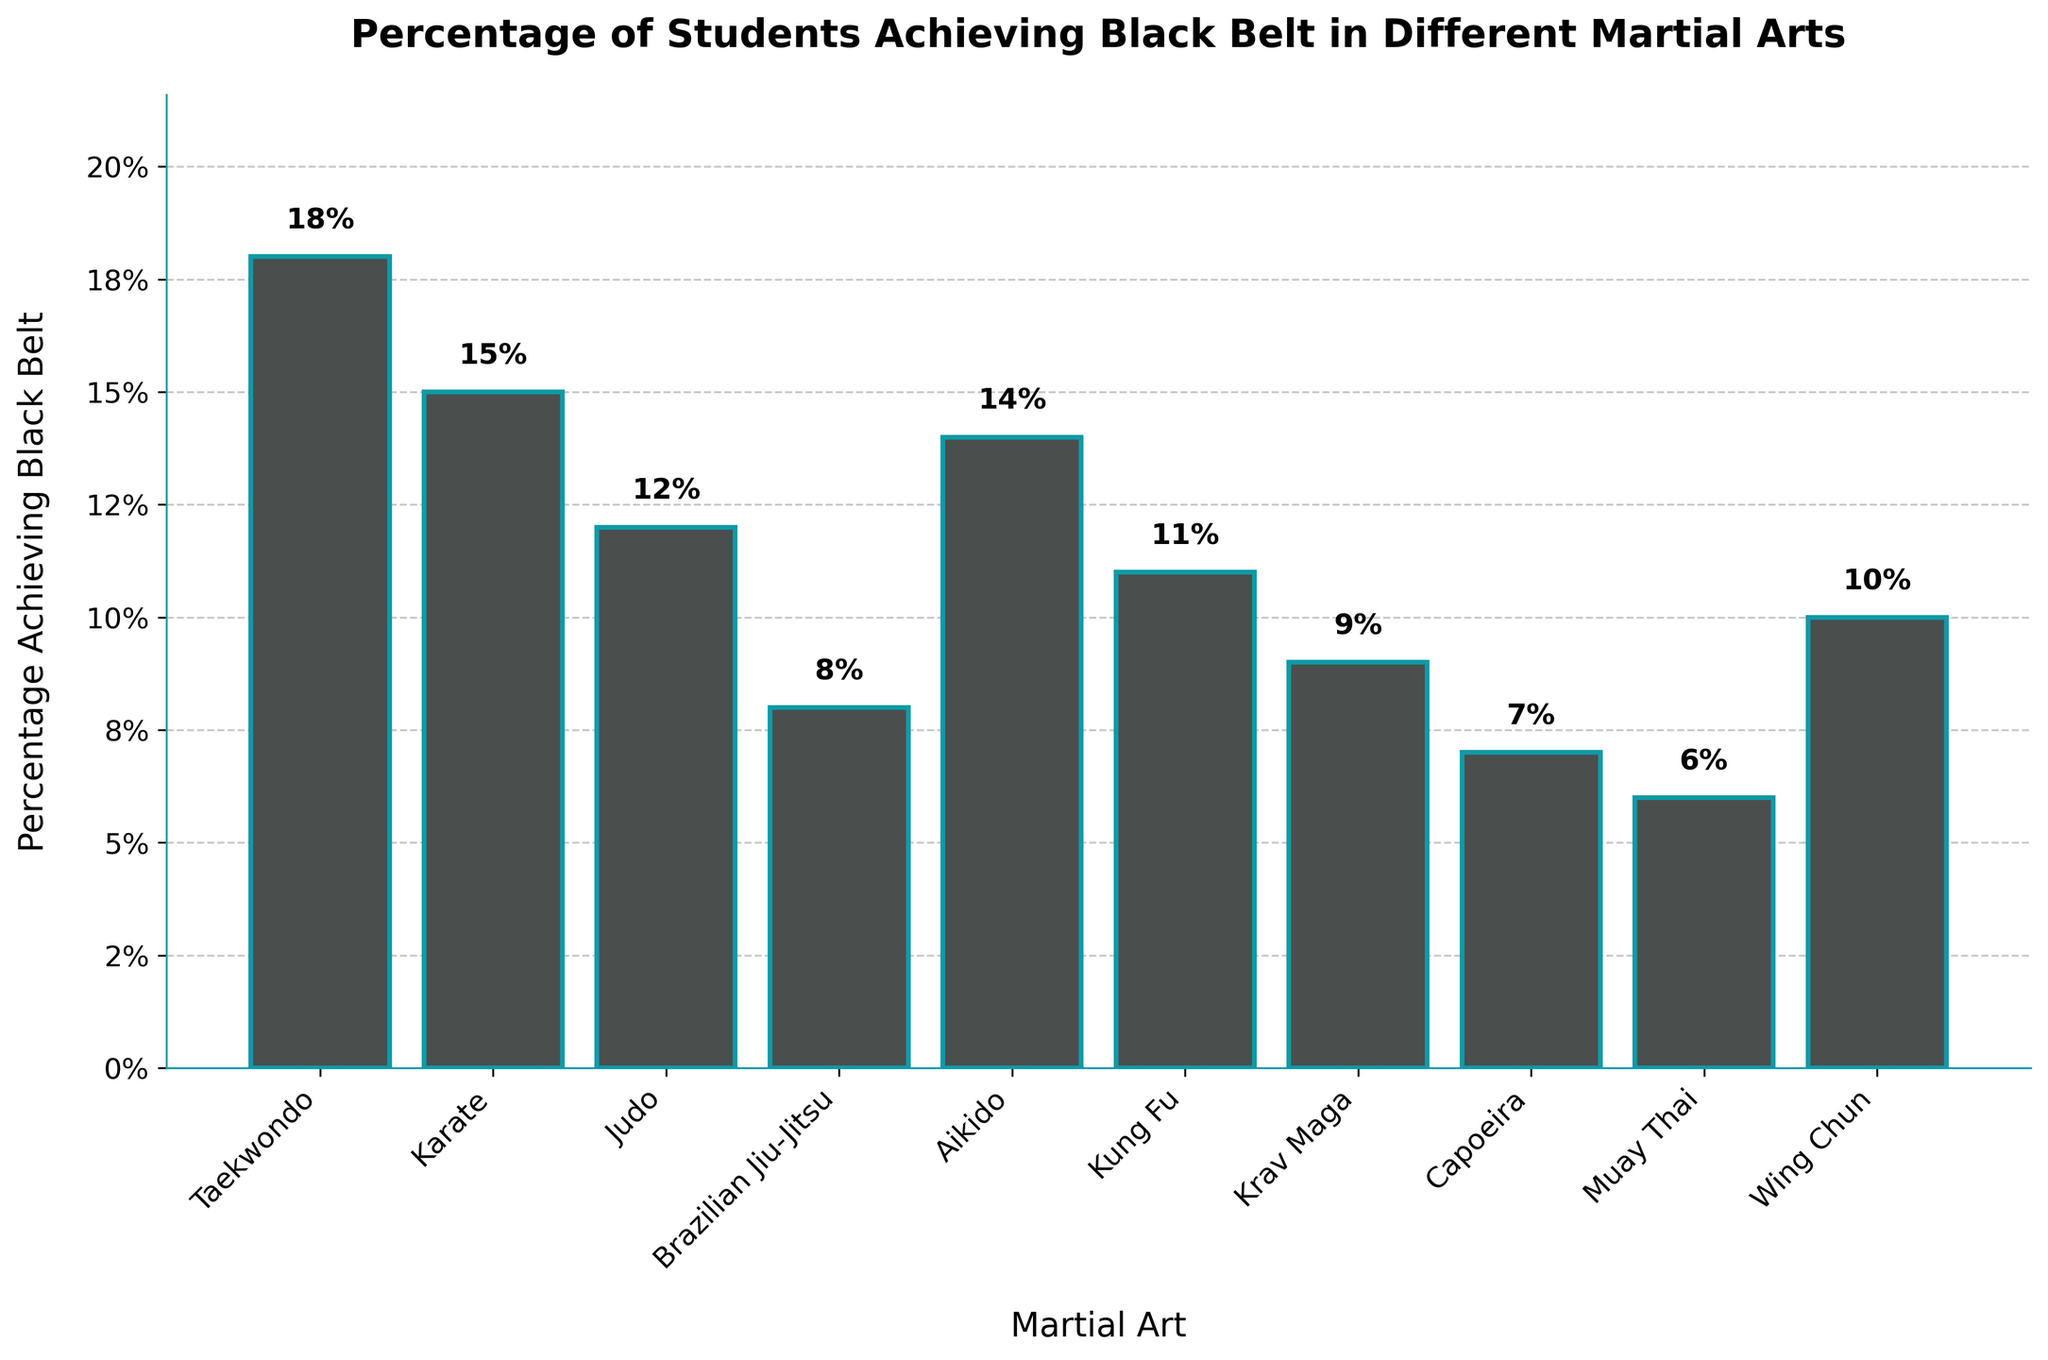What's the highest percentage of students achieving black belt among the martial arts listed? The figure shows a bar for each martial art with the percentage of students achieving black belt. The tallest bar represents the highest percentage. The Taekwondo bar is the tallest, indicating it has the highest percentage.
Answer: Taekwondo Which martial art has the lowest percentage of students achieving black belt? The figure shows a bar for each martial art. The shortest bar represents the lowest percentage of students achieving black belt. The Muay Thai bar is the shortest.
Answer: Muay Thai Compare the percentage of students achieving black belt in Karate and Brazilian Jiu-Jitsu. Which is higher? The Karate bar is taller than the Brazilian Jiu-Jitsu bar.
Answer: Karate What is the difference in the percentage of students achieving black belt between Judo and Capoeira? The percentage for Judo is 12% and for Capoeira is 7%. The difference is calculated as 12% - 7% = 5%.
Answer: 5% Which martial arts have a percentage of students achieving black belt equal to or greater than 10%? Identify bars with a height of 10% or more. Taekwondo, Karate, Aikido, and Wing Chun all meet this criterion.
Answer: Taekwondo, Karate, Aikido, Wing Chun What is the average percentage of students achieving black belt across all martial arts? Add all percentages: 18 + 15 + 12 + 8 + 14 + 11 + 9 + 7 + 6 + 10 = 100. There are 10 martial arts, so the average is 100 ÷ 10 = 10%.
Answer: 10% How many martial arts have a percentage of students achieving black belt less than 10%? Count the bars that are shorter than the 10% mark. There are four such bars: Brazilian Jiu-Jitsu, Krav Maga, Capoeira, and Muay Thai.
Answer: 4 What is the combined percentage of students achieving black belt in Kung Fu and Wing Chun? Add the percentages for Kung Fu and Wing Chun which are 11% and 10% respectively: 11% + 10% = 21%.
Answer: 21% Is the percentage of students achieving black belt in Aikido higher than in Kung Fu? Compare the heights of the Aikido and Kung Fu bars. The Aikido bar is taller than the Kung Fu bar.
Answer: Yes 